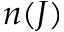Convert formula to latex. <formula><loc_0><loc_0><loc_500><loc_500>n ( J )</formula> 